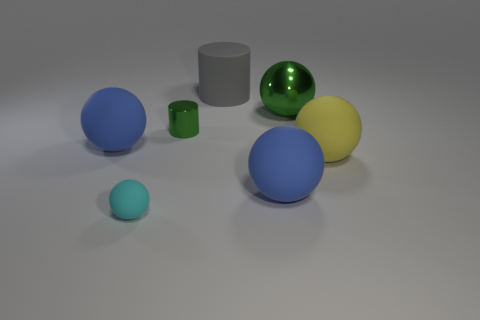There is a tiny thing that is behind the yellow rubber object; what is it made of?
Your answer should be very brief. Metal. Is the shape of the cyan thing the same as the rubber object right of the large shiny ball?
Provide a short and direct response. Yes. Are there more metallic objects than small rubber objects?
Make the answer very short. Yes. Is there anything else that is the same color as the shiny sphere?
Your answer should be compact. Yes. What is the shape of the object that is the same material as the green ball?
Provide a succinct answer. Cylinder. There is a tiny thing behind the ball right of the green shiny sphere; what is its material?
Ensure brevity in your answer.  Metal. There is a big blue object that is to the right of the gray cylinder; is its shape the same as the big gray matte object?
Give a very brief answer. No. Is the number of blue objects that are on the left side of the large cylinder greater than the number of tiny gray cylinders?
Provide a succinct answer. Yes. What is the shape of the shiny object that is the same color as the big shiny ball?
Offer a terse response. Cylinder. What number of spheres are either gray objects or large metal things?
Offer a very short reply. 1. 